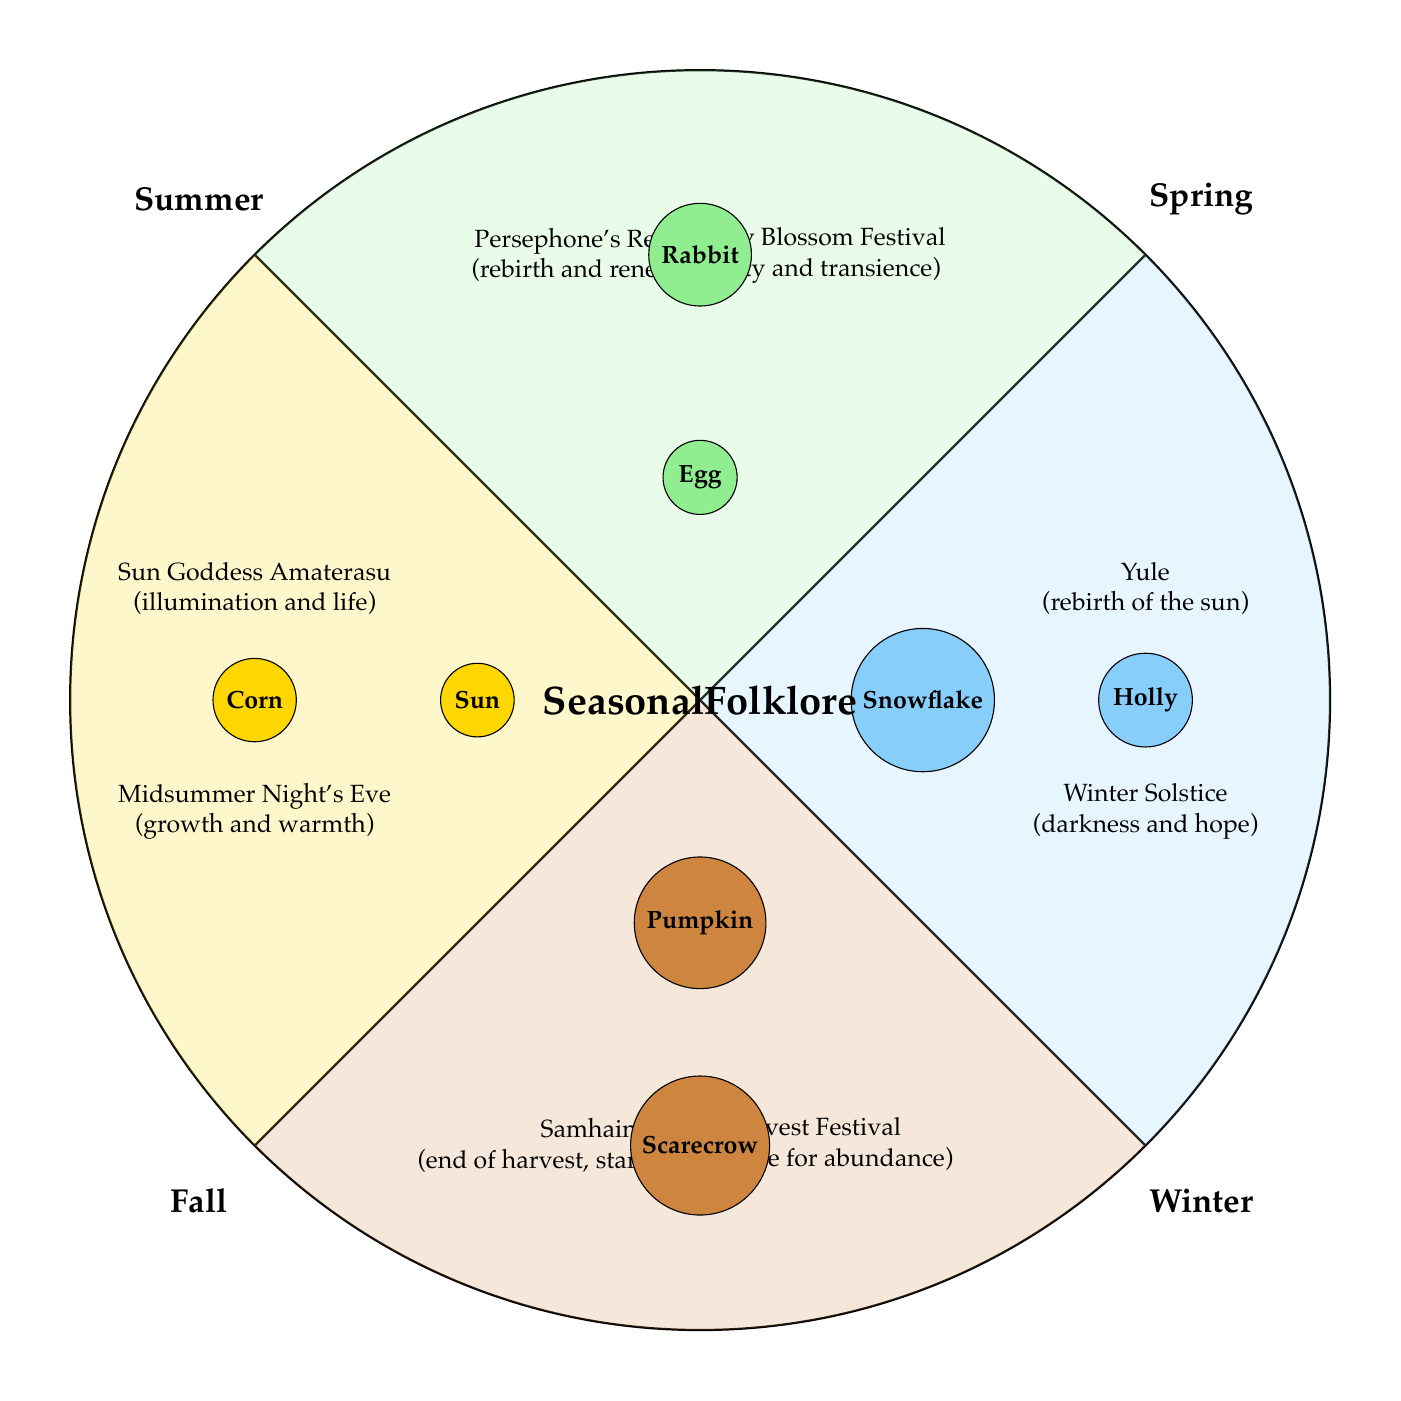What folklore is associated with Spring? The diagram indicates that the stories linked to Spring include "Persephone's Return" and "Cherry Blossom Festival." Both symbolize rebirth and renewal, as well as beauty and transience.
Answer: Persephone's Return, Cherry Blossom Festival What symbol is used in the Summer quadrant? In the Summer section of the diagram, it shows a sun and corn as important symbols, representing growth and life.
Answer: Sun, Corn How many folklore legends are included in the Fall quadrant? In the Fall section, there are two folklore legends identified: "Harvest Festival" and "Samhain." This totals up to two legends.
Answer: 2 What does the Winter Solstice symbolize? According to the diagram, the Winter Solstice is associated with themes of darkness and hope, indicating a duality in this period.
Answer: Darkness and hope Which season features the rabbit as a symbol? The diagram lists "Rabbit" in the Spring quadrant, signifying themes of rebirth and renewal related to this season.
Answer: Spring What is the primary color representing Summer in the diagram? The Summer quadrant is represented using a vibrant yellow color, symbolizing warmth and brightness typical of the season.
Answer: Yellow What two seasons focus on rebirth? The diagram shows "Persephone's Return" in Spring and "Yule" in Winter as both stories capture themes of rebirth during their respective seasons.
Answer: Spring, Winter Which festival is linked to gratitude in Fall? The diagram highlights "Harvest Festival" in the Fall section, which symbolizes gratitude for abundance in the harvest.
Answer: Harvest Festival What is the main theme of Midsummer Night's Eve? The diagram states that Midsummer Night's Eve represents growth and warmth, central characteristics associated with the Summer season.
Answer: Growth and warmth 